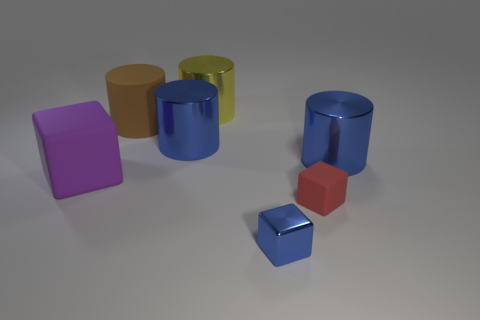Subtract all blue cylinders. How many were subtracted if there are1blue cylinders left? 1 Add 3 purple rubber things. How many objects exist? 10 Subtract all cyan balls. How many blue cylinders are left? 2 Subtract all matte blocks. How many blocks are left? 1 Subtract 2 cylinders. How many cylinders are left? 2 Subtract all cylinders. How many objects are left? 3 Subtract all brown cylinders. How many cylinders are left? 3 Subtract all small red things. Subtract all large yellow cylinders. How many objects are left? 5 Add 3 purple things. How many purple things are left? 4 Add 6 red matte blocks. How many red matte blocks exist? 7 